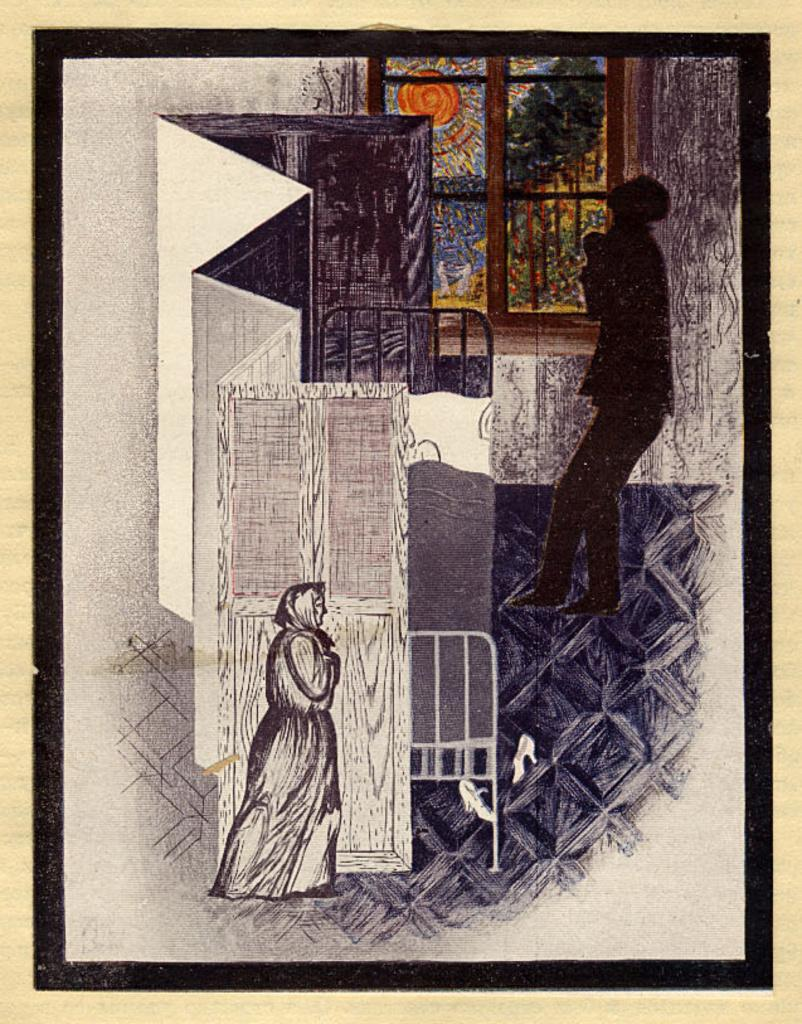What type of artwork is shown in the image? The image is a painting. What is the main subject of the painting? The painting depicts a woman. Can you describe the gender of the person in the painting? The painting also depicts a human, who is a woman. How does the quiet slip into the painting? There is no mention of a quiet slip in the image or the provided facts. 